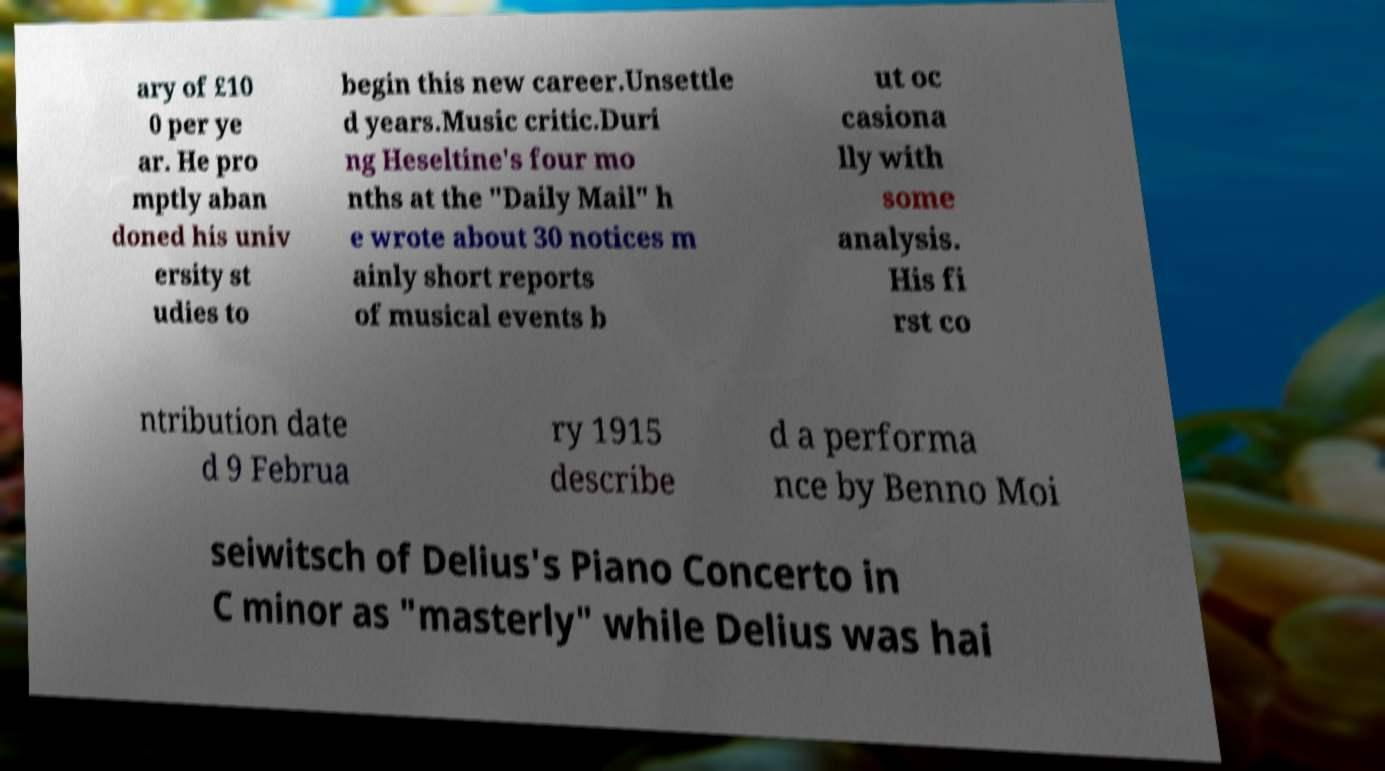I need the written content from this picture converted into text. Can you do that? ary of £10 0 per ye ar. He pro mptly aban doned his univ ersity st udies to begin this new career.Unsettle d years.Music critic.Duri ng Heseltine's four mo nths at the "Daily Mail" h e wrote about 30 notices m ainly short reports of musical events b ut oc casiona lly with some analysis. His fi rst co ntribution date d 9 Februa ry 1915 describe d a performa nce by Benno Moi seiwitsch of Delius's Piano Concerto in C minor as "masterly" while Delius was hai 